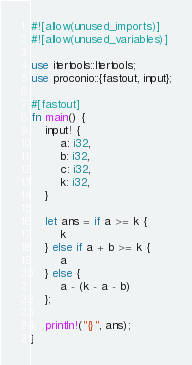Convert code to text. <code><loc_0><loc_0><loc_500><loc_500><_Rust_>#![allow(unused_imports)]
#![allow(unused_variables)]

use itertools::Itertools;
use proconio::{fastout, input};

#[fastout]
fn main() {
    input! {
        a: i32,
        b: i32,
        c: i32,
        k: i32,
    }

    let ans = if a >= k {
        k
    } else if a + b >= k {
        a
    } else {
        a - (k - a - b)
    };

    println!("{}", ans);
}
</code> 